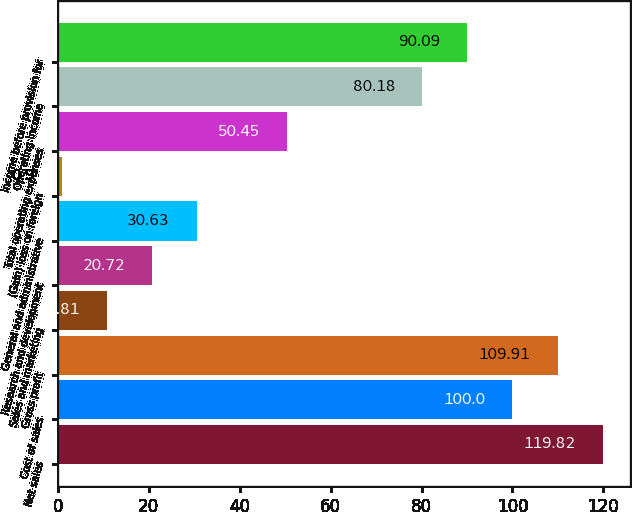Convert chart. <chart><loc_0><loc_0><loc_500><loc_500><bar_chart><fcel>Net sales<fcel>Cost of sales<fcel>Gross profit<fcel>Sales and marketing<fcel>Research and development<fcel>General and administrative<fcel>(Gain) loss on foreign<fcel>Total operating expenses<fcel>Operating income<fcel>Income before provision for<nl><fcel>119.82<fcel>100<fcel>109.91<fcel>10.81<fcel>20.72<fcel>30.63<fcel>0.9<fcel>50.45<fcel>80.18<fcel>90.09<nl></chart> 